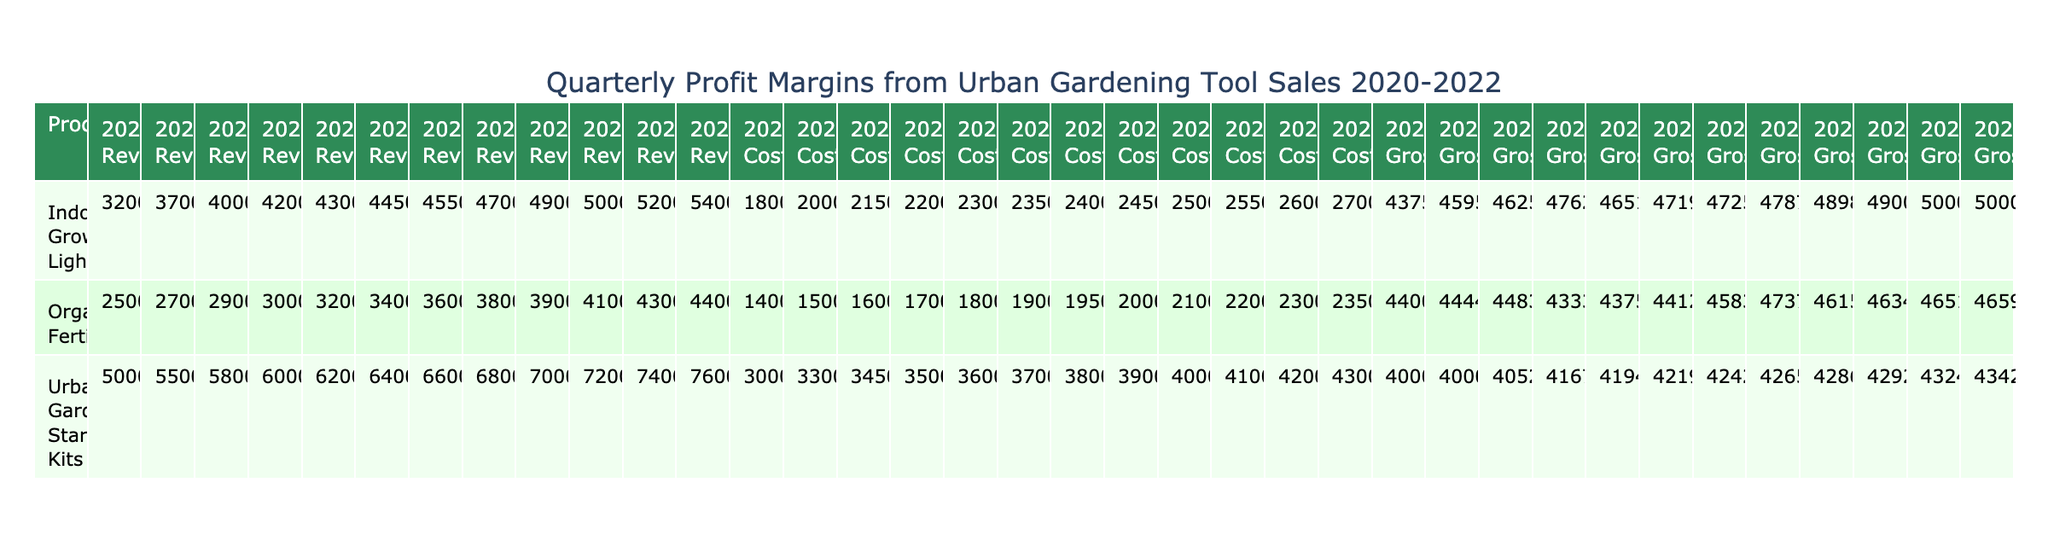What was the gross profit margin for Indoor Grow Lights in Q2 2021? In Q2 2021, the gross profit margin for Indoor Grow Lights is clearly listed in the table as 47.19%.
Answer: 47.19% Which product had the highest gross profit margin in Q3 2022? By reviewing the gross profit margins for products in Q3 2022, Indoor Grow Lights had the maximum at 50%.
Answer: 50% What was the total revenue from Urban Gardening Starter Kits across all quarters in 2020? The revenues from Urban Gardening Starter Kits in 2020 are 50000 (Q1) + 55000 (Q2) + 58000 (Q3) + 60000 (Q4) = 223000.
Answer: 223000 Was there an increase in the gross profit margin for Organic Fertilizers from Q1 2020 to Q4 2022? The gross profit margin for Organic Fertilizers increased from 44% in Q1 2020 to 46.59% in Q4 2022, indicating a positive trend.
Answer: Yes What was the percentage increase in revenue for Indoor Grow Lights from Q1 2020 to Q1 2022? The revenue in Q1 2020 was 32000, and in Q1 2022 it was 49000. The increase is (49000 - 32000) / 32000 * 100 = 53.125%.
Answer: 53.13% Which quarter had the lowest gross profit margin for Urban Gardening Starter Kits? Checking the table, Q1 2020 had the lowest gross profit margin for Urban Gardening Starter Kits at 40%.
Answer: Q1 2020 What is the average gross profit margin for Indoor Grow Lights throughout 2020? The gross profit margins for Indoor Grow Lights in 2020 were 43.75%, 46.25%, and 47.62%. Summing these values and dividing by 3 gives (43.75 + 46.25 + 47.62)/3 = 45.54%.
Answer: 45.54% Did Urban Gardening Starter Kits achieve a gross profit margin above 42% in every quarter of 2021? In examining the gross profit margins for Urban Gardening Starter Kits in 2021, Q1, Q2, Q3, and Q4 recorded margins of 41.94%, 42.19%, 42.42%, and 42.65% respectively. Only Q1 fell slightly below 42%, making the statement false.
Answer: No Which product consistently had the highest gross profit margins in 2021? Upon reviewing the gross profit margins for 2021, Indoor Grow Lights had the highest percentages across all quarters: 46.51%, 47.19%, 47.25%, and 47.87%.
Answer: Indoor Grow Lights 